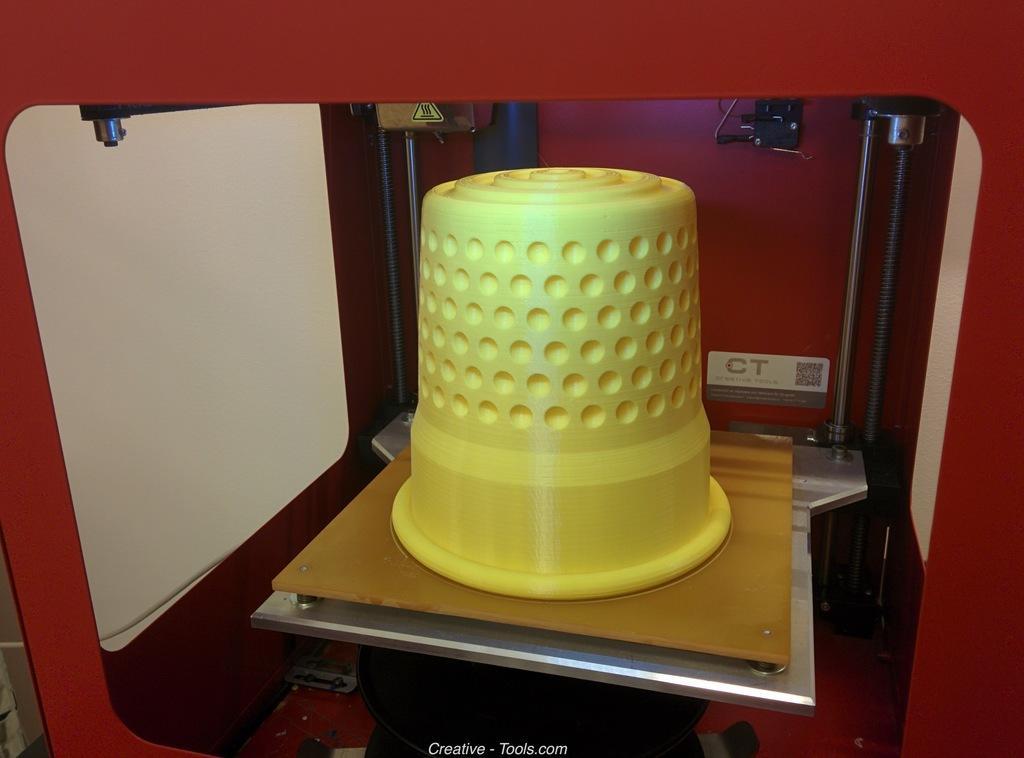Can you describe this image briefly? This image consists of a basket in yellow color. It is kept in a machine. It looks like a CNC machine. The machine is in red color. 